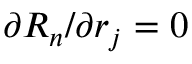<formula> <loc_0><loc_0><loc_500><loc_500>{ \partial R _ { n } } / { \partial r _ { j } } = 0</formula> 